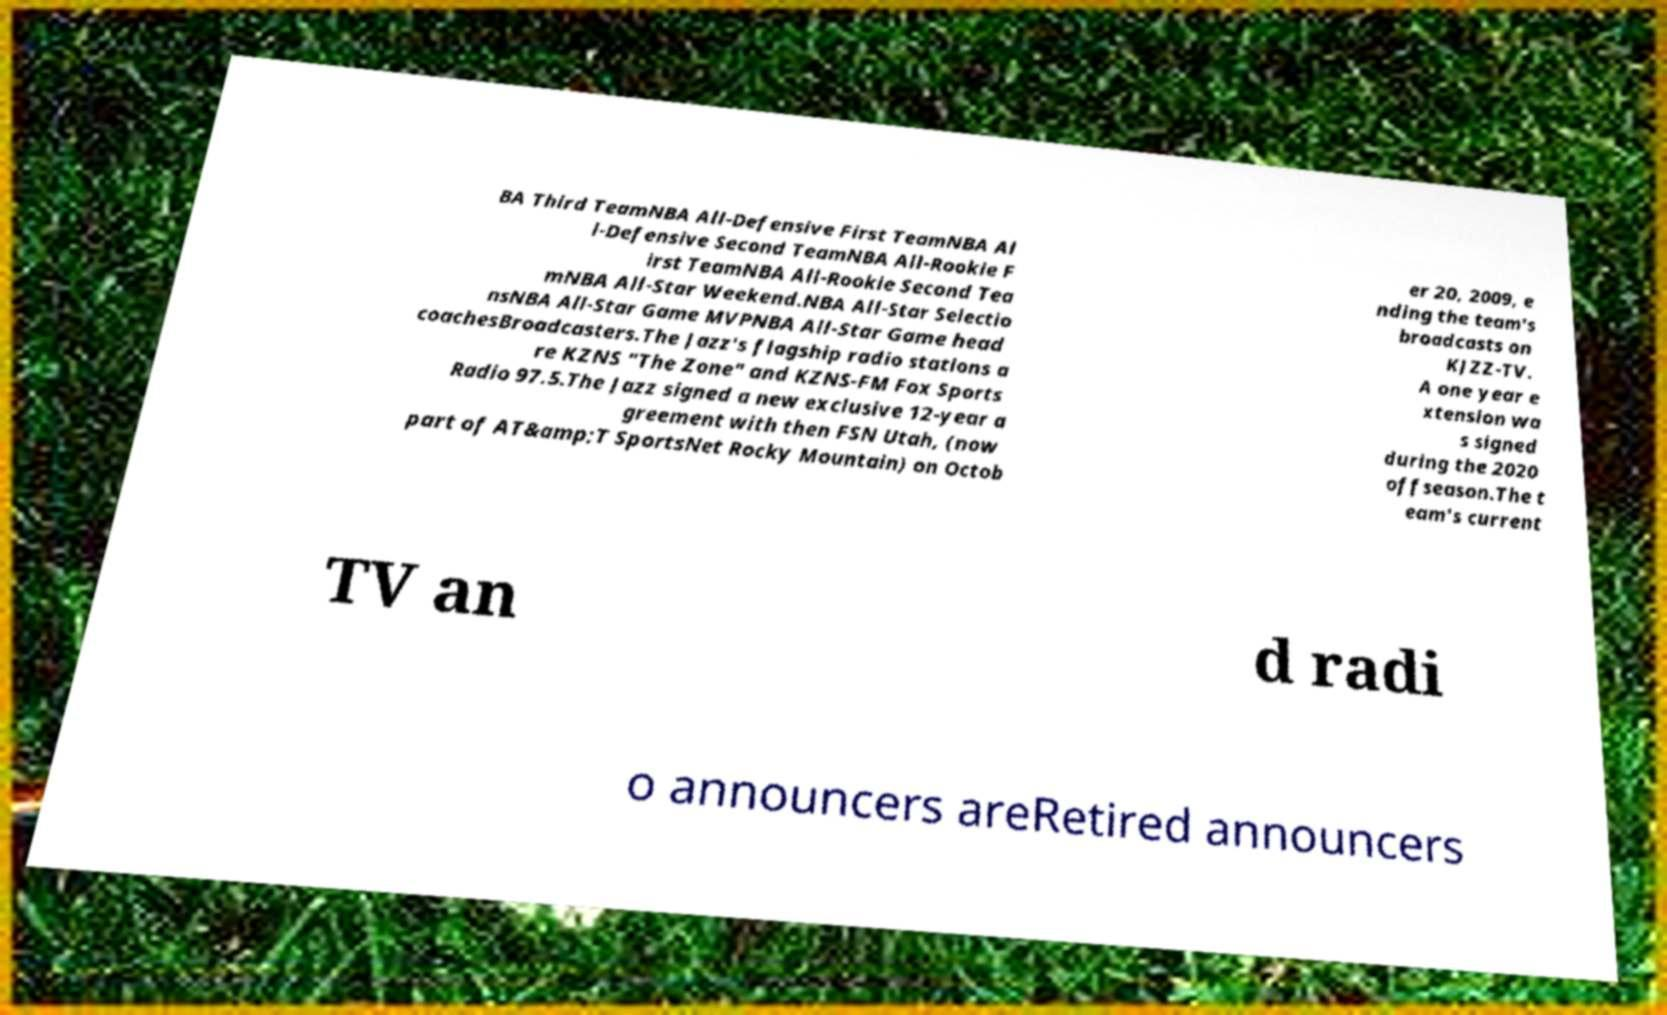I need the written content from this picture converted into text. Can you do that? BA Third TeamNBA All-Defensive First TeamNBA Al l-Defensive Second TeamNBA All-Rookie F irst TeamNBA All-Rookie Second Tea mNBA All-Star Weekend.NBA All-Star Selectio nsNBA All-Star Game MVPNBA All-Star Game head coachesBroadcasters.The Jazz's flagship radio stations a re KZNS "The Zone" and KZNS-FM Fox Sports Radio 97.5.The Jazz signed a new exclusive 12-year a greement with then FSN Utah, (now part of AT&amp;T SportsNet Rocky Mountain) on Octob er 20, 2009, e nding the team's broadcasts on KJZZ-TV. A one year e xtension wa s signed during the 2020 offseason.The t eam's current TV an d radi o announcers areRetired announcers 